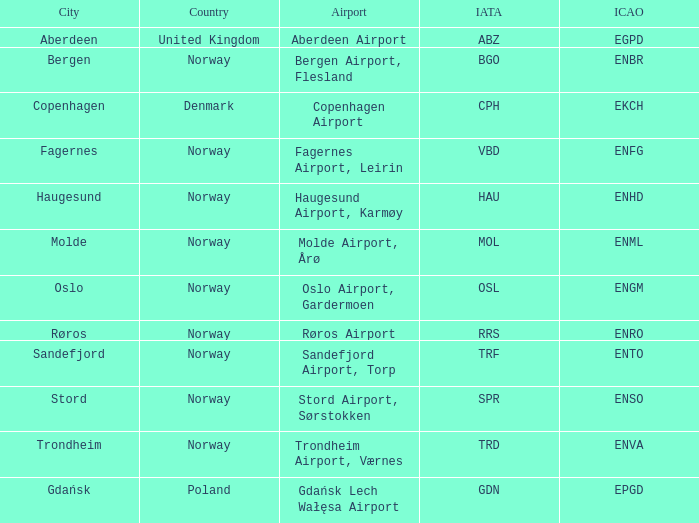What is th IATA for Norway with an ICAO of ENTO? TRF. 